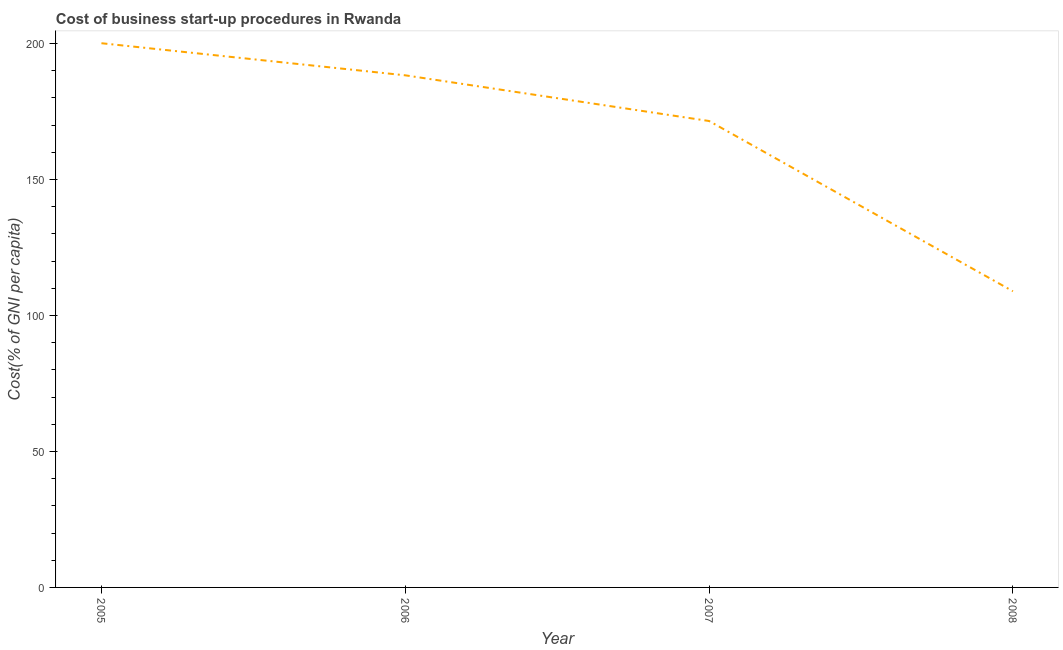What is the cost of business startup procedures in 2007?
Ensure brevity in your answer.  171.5. Across all years, what is the maximum cost of business startup procedures?
Offer a terse response. 200.1. Across all years, what is the minimum cost of business startup procedures?
Your response must be concise. 108.9. In which year was the cost of business startup procedures maximum?
Give a very brief answer. 2005. In which year was the cost of business startup procedures minimum?
Your answer should be very brief. 2008. What is the sum of the cost of business startup procedures?
Make the answer very short. 668.8. What is the difference between the cost of business startup procedures in 2007 and 2008?
Your answer should be very brief. 62.6. What is the average cost of business startup procedures per year?
Offer a terse response. 167.2. What is the median cost of business startup procedures?
Provide a short and direct response. 179.9. What is the ratio of the cost of business startup procedures in 2007 to that in 2008?
Offer a terse response. 1.57. Is the cost of business startup procedures in 2005 less than that in 2008?
Ensure brevity in your answer.  No. What is the difference between the highest and the second highest cost of business startup procedures?
Offer a terse response. 11.8. Is the sum of the cost of business startup procedures in 2005 and 2008 greater than the maximum cost of business startup procedures across all years?
Provide a succinct answer. Yes. What is the difference between the highest and the lowest cost of business startup procedures?
Keep it short and to the point. 91.2. Does the cost of business startup procedures monotonically increase over the years?
Ensure brevity in your answer.  No. How many lines are there?
Provide a succinct answer. 1. What is the difference between two consecutive major ticks on the Y-axis?
Offer a terse response. 50. Does the graph contain any zero values?
Provide a succinct answer. No. Does the graph contain grids?
Your response must be concise. No. What is the title of the graph?
Provide a short and direct response. Cost of business start-up procedures in Rwanda. What is the label or title of the X-axis?
Offer a terse response. Year. What is the label or title of the Y-axis?
Your response must be concise. Cost(% of GNI per capita). What is the Cost(% of GNI per capita) in 2005?
Offer a very short reply. 200.1. What is the Cost(% of GNI per capita) in 2006?
Your answer should be very brief. 188.3. What is the Cost(% of GNI per capita) in 2007?
Ensure brevity in your answer.  171.5. What is the Cost(% of GNI per capita) in 2008?
Your response must be concise. 108.9. What is the difference between the Cost(% of GNI per capita) in 2005 and 2007?
Make the answer very short. 28.6. What is the difference between the Cost(% of GNI per capita) in 2005 and 2008?
Your response must be concise. 91.2. What is the difference between the Cost(% of GNI per capita) in 2006 and 2007?
Your response must be concise. 16.8. What is the difference between the Cost(% of GNI per capita) in 2006 and 2008?
Ensure brevity in your answer.  79.4. What is the difference between the Cost(% of GNI per capita) in 2007 and 2008?
Offer a terse response. 62.6. What is the ratio of the Cost(% of GNI per capita) in 2005 to that in 2006?
Provide a short and direct response. 1.06. What is the ratio of the Cost(% of GNI per capita) in 2005 to that in 2007?
Ensure brevity in your answer.  1.17. What is the ratio of the Cost(% of GNI per capita) in 2005 to that in 2008?
Ensure brevity in your answer.  1.84. What is the ratio of the Cost(% of GNI per capita) in 2006 to that in 2007?
Offer a very short reply. 1.1. What is the ratio of the Cost(% of GNI per capita) in 2006 to that in 2008?
Provide a short and direct response. 1.73. What is the ratio of the Cost(% of GNI per capita) in 2007 to that in 2008?
Ensure brevity in your answer.  1.57. 